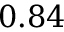<formula> <loc_0><loc_0><loc_500><loc_500>0 . 8 4</formula> 